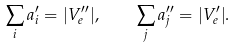Convert formula to latex. <formula><loc_0><loc_0><loc_500><loc_500>\sum _ { i } a _ { i } ^ { \prime } = | V ^ { \prime \prime } _ { e } | , \quad \sum _ { j } a _ { j } ^ { \prime \prime } = | V ^ { \prime } _ { e } | .</formula> 